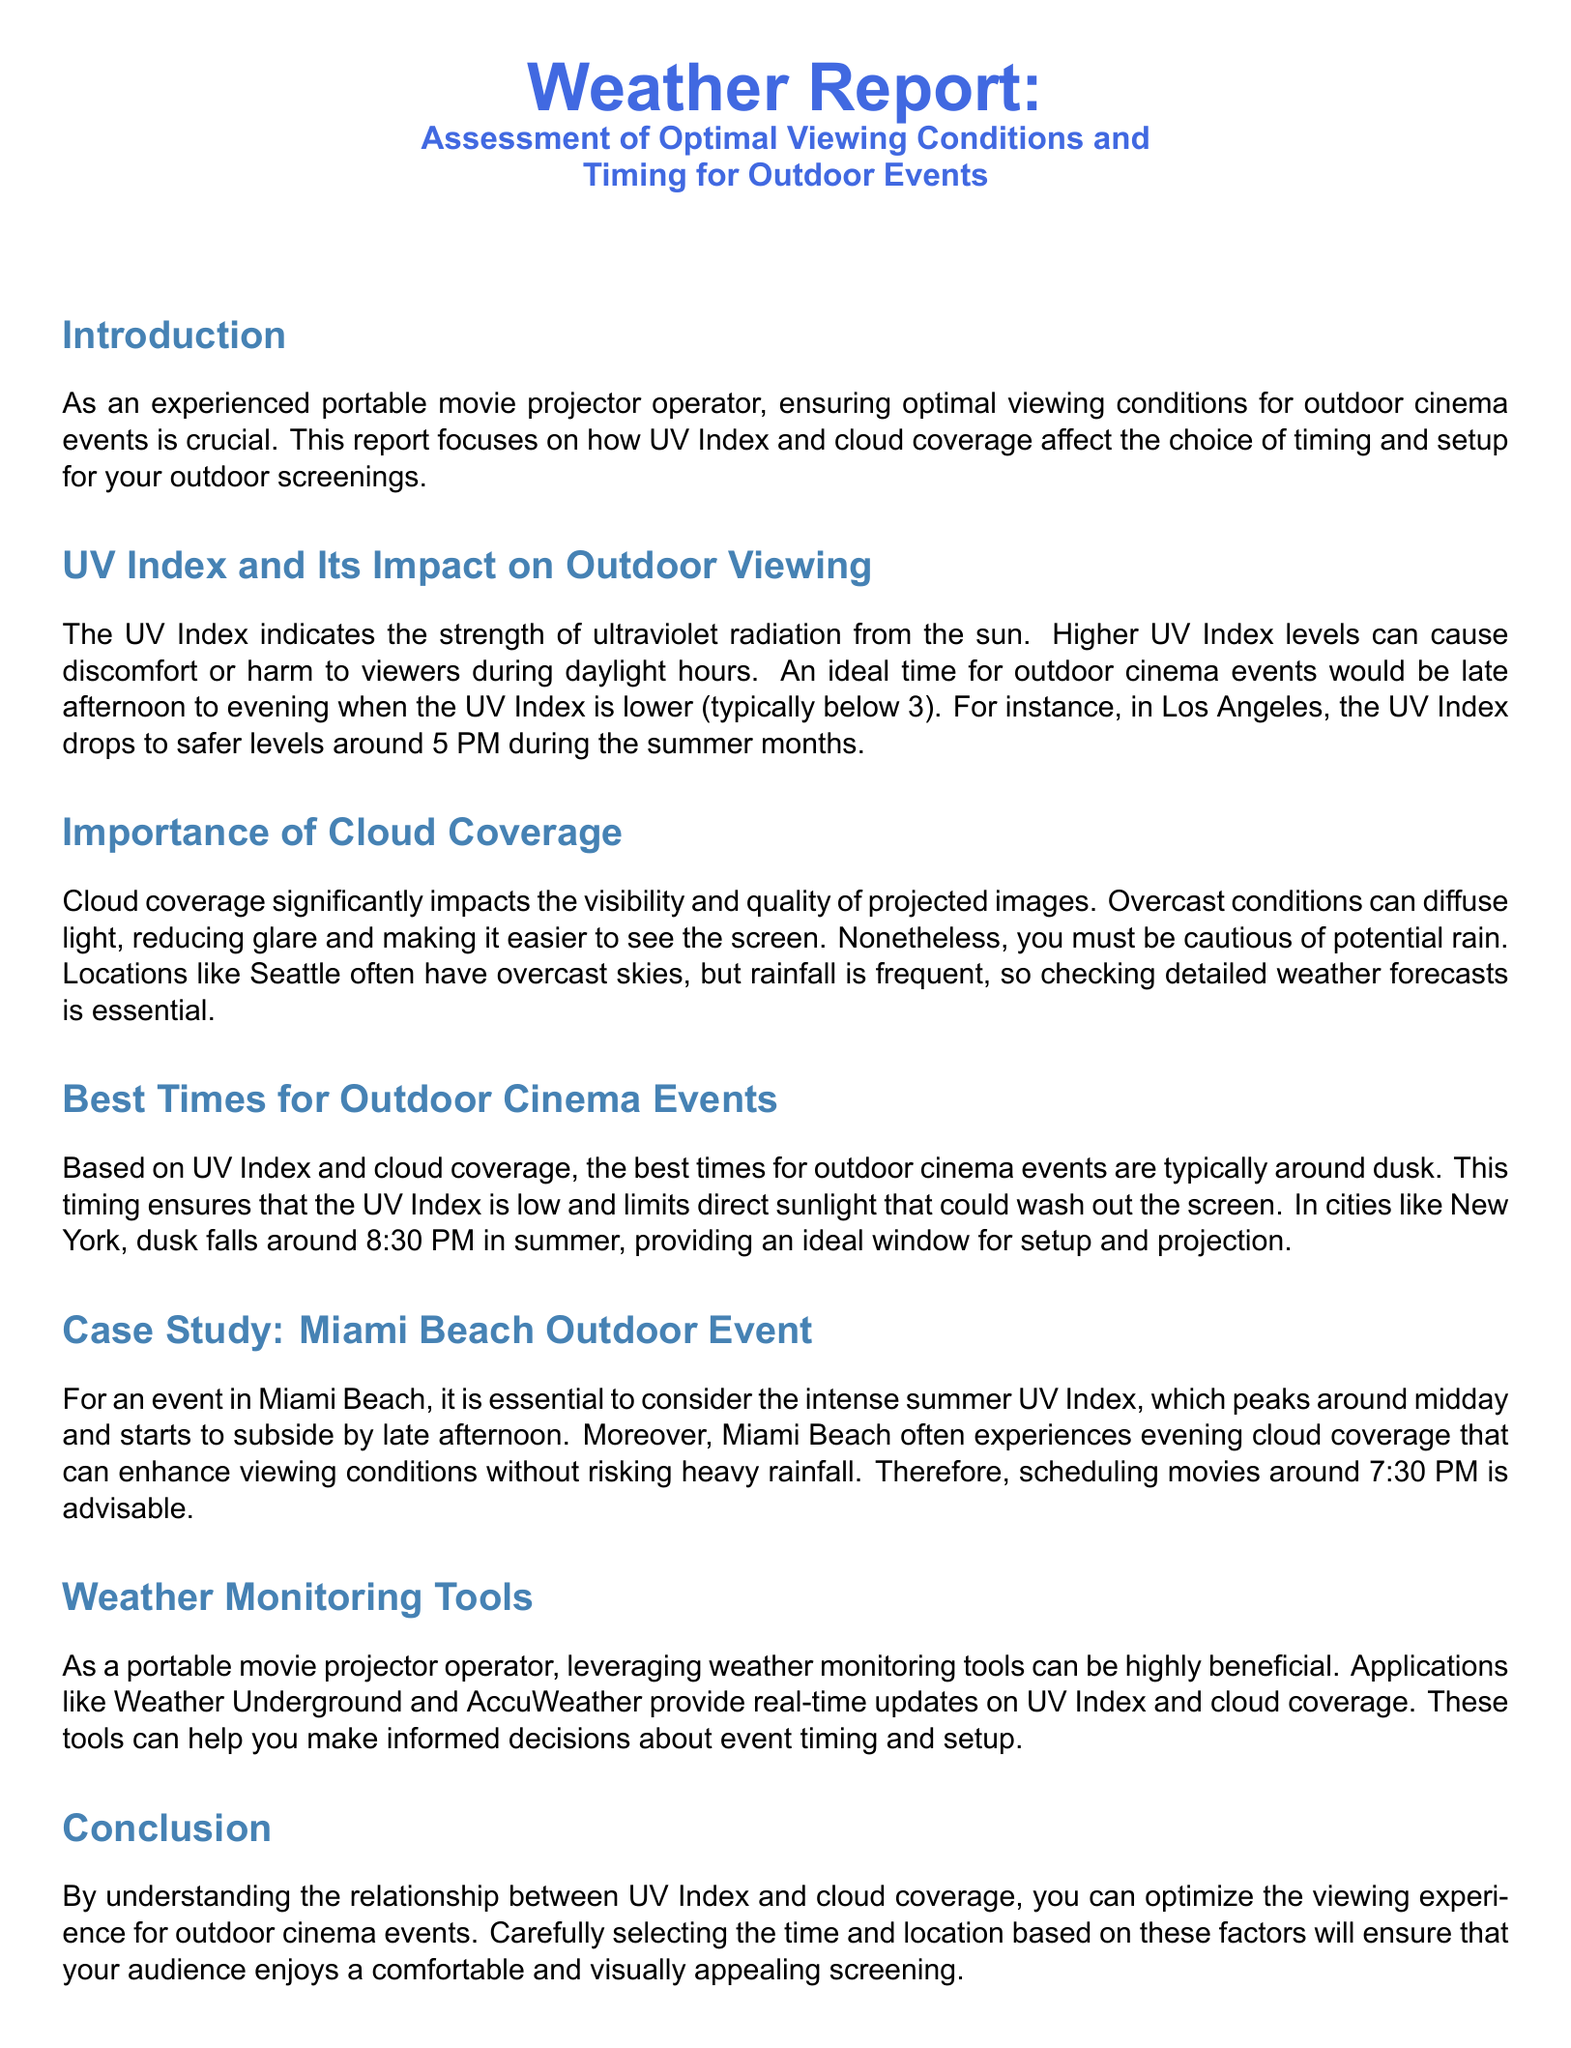What is the ideal UV Index level for outdoor cinema events? The document specifies that an ideal time for outdoor cinema events would be when the UV Index is lower, typically below 3.
Answer: below 3 At what time does the UV Index drop to safer levels in Los Angeles during summer? The document states that in Los Angeles, the UV Index drops to safer levels around 5 PM during the summer months.
Answer: 5 PM What is the recommended schedule for movies in Miami Beach? The document advises that for an event in Miami Beach, scheduling movies around 7:30 PM is advisable.
Answer: 7:30 PM How does cloud coverage affect projected images? The report mentions that cloud coverage significantly impacts visibility by diffusing light, reducing glare, and making it easier to see the screen.
Answer: reduces glare Which cities experience ideal dusk times around 8:30 PM in summer? According to the document, New York is mentioned as a city where dusk falls around 8:30 PM in summer.
Answer: New York What tools can portable movie projector operators use for weather monitoring? The report suggests that applications like Weather Underground and AccuWeather can provide real-time updates on UV Index and cloud coverage.
Answer: Weather Underground and AccuWeather What is a potential downside of overcast conditions in Seattle? The document points out that while Seattle often has overcast skies, rainfall is frequent, making it necessary to check detailed weather forecasts.
Answer: potential rain What is the main focus of this weather report? The report focuses on how UV Index and cloud coverage affect the choice of timing and setup for outdoor screenings.
Answer: timing and setup for outdoor screenings 